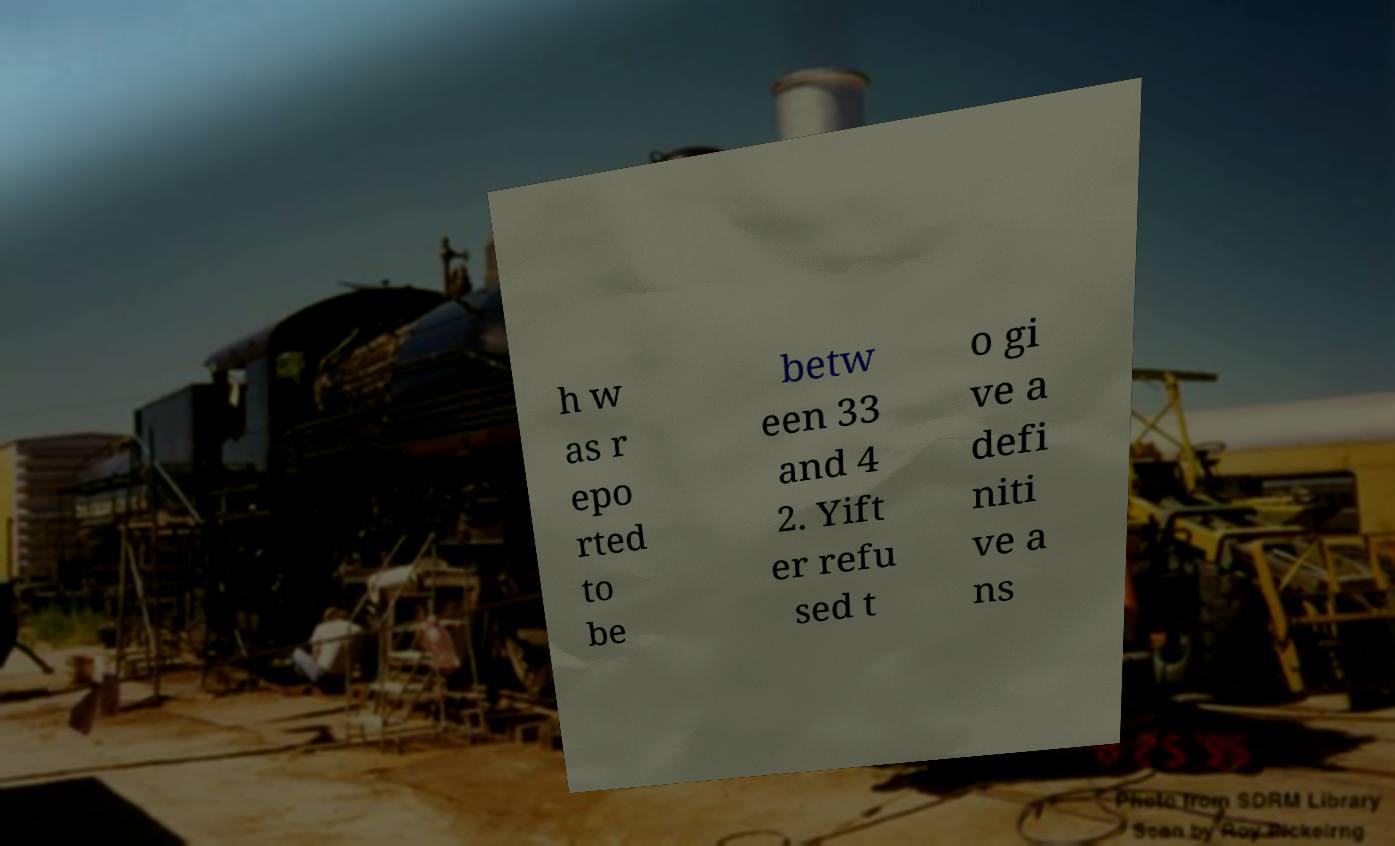Could you extract and type out the text from this image? h w as r epo rted to be betw een 33 and 4 2. Yift er refu sed t o gi ve a defi niti ve a ns 